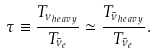<formula> <loc_0><loc_0><loc_500><loc_500>\tau \equiv \frac { T _ { \nu _ { h e a v y } } } { T _ { \bar { \nu } _ { e } } } \simeq \frac { T _ { \bar { \nu } _ { h e a v y } } } { T _ { \bar { \nu } _ { e } } } .</formula> 